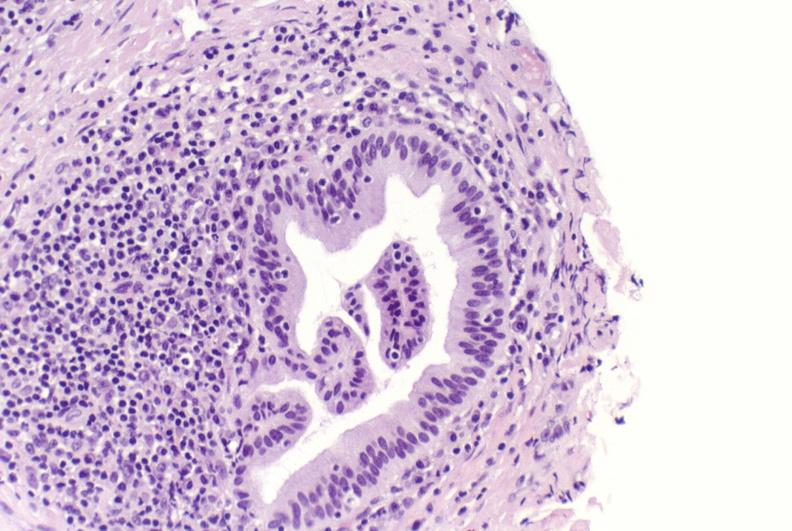s child present?
Answer the question using a single word or phrase. No 